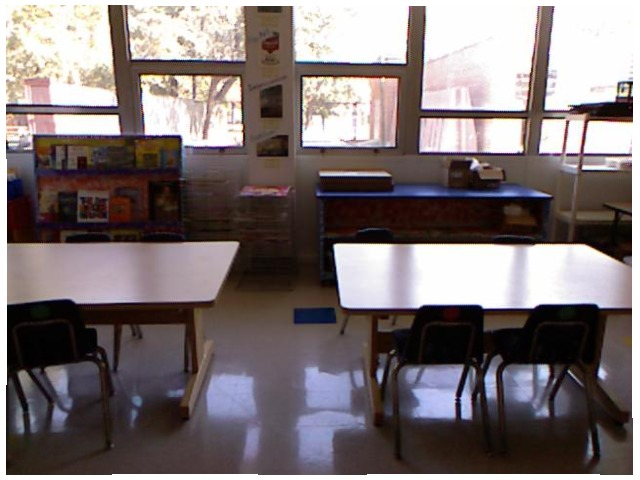<image>
Is there a table to the right of the window? No. The table is not to the right of the window. The horizontal positioning shows a different relationship. Is there a chair to the left of the table? No. The chair is not to the left of the table. From this viewpoint, they have a different horizontal relationship. 